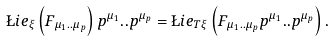Convert formula to latex. <formula><loc_0><loc_0><loc_500><loc_500>\L i e _ { \xi } \left ( F _ { \mu _ { 1 } . . \mu _ { p } } \right ) p ^ { \mu _ { 1 } } . . p ^ { \mu _ { p } } = \L i e _ { T \xi } \left ( F _ { \mu _ { 1 } . . \mu _ { p } } p ^ { \mu _ { 1 } } . . p ^ { \mu _ { p } } \right ) .</formula> 